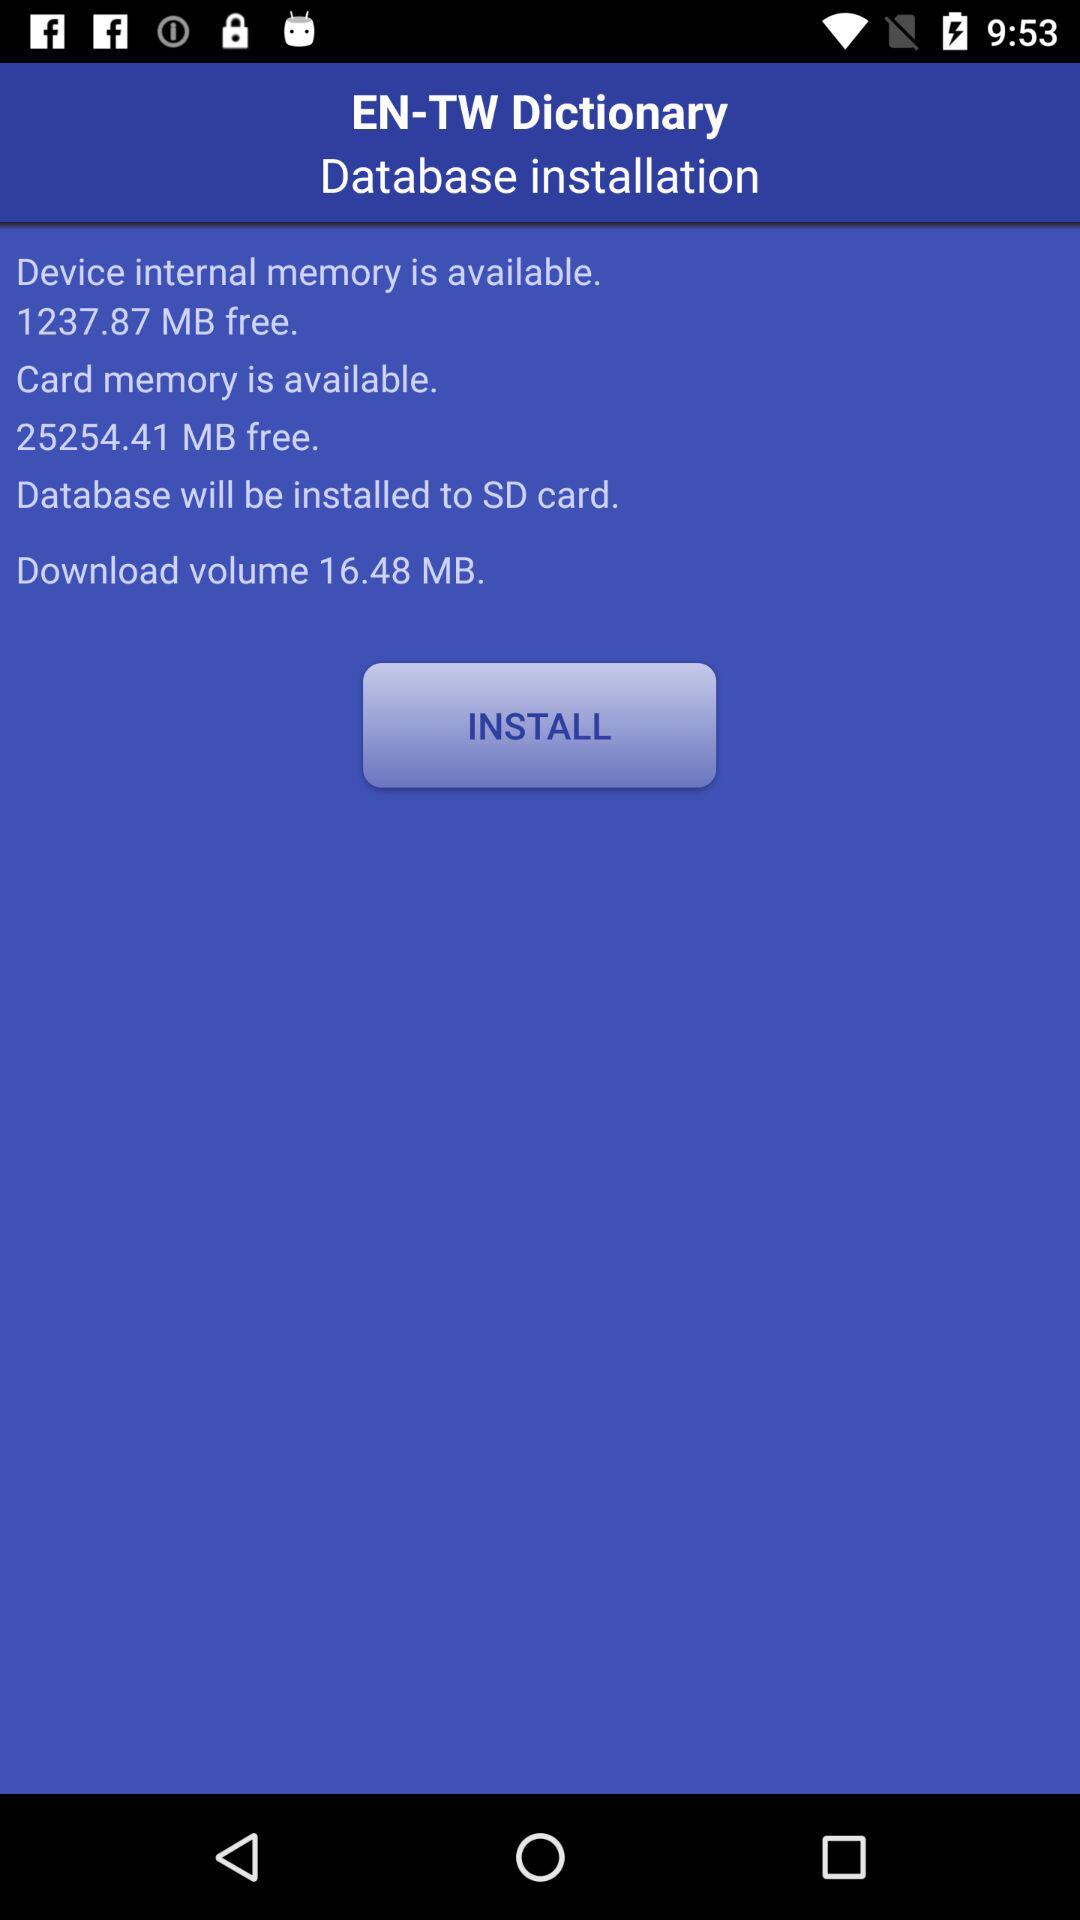Where will the database be installed? The database will be installed to SD card. 